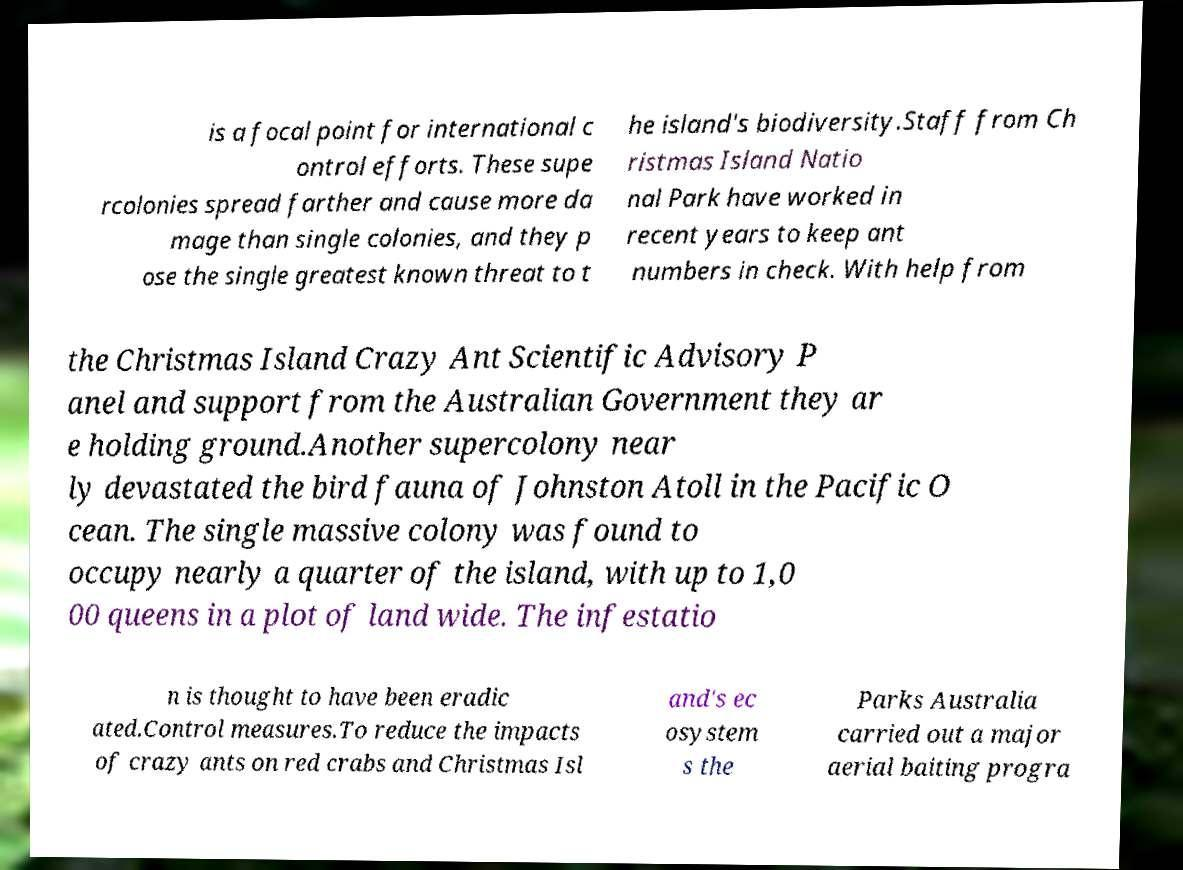Could you assist in decoding the text presented in this image and type it out clearly? is a focal point for international c ontrol efforts. These supe rcolonies spread farther and cause more da mage than single colonies, and they p ose the single greatest known threat to t he island's biodiversity.Staff from Ch ristmas Island Natio nal Park have worked in recent years to keep ant numbers in check. With help from the Christmas Island Crazy Ant Scientific Advisory P anel and support from the Australian Government they ar e holding ground.Another supercolony near ly devastated the bird fauna of Johnston Atoll in the Pacific O cean. The single massive colony was found to occupy nearly a quarter of the island, with up to 1,0 00 queens in a plot of land wide. The infestatio n is thought to have been eradic ated.Control measures.To reduce the impacts of crazy ants on red crabs and Christmas Isl and's ec osystem s the Parks Australia carried out a major aerial baiting progra 